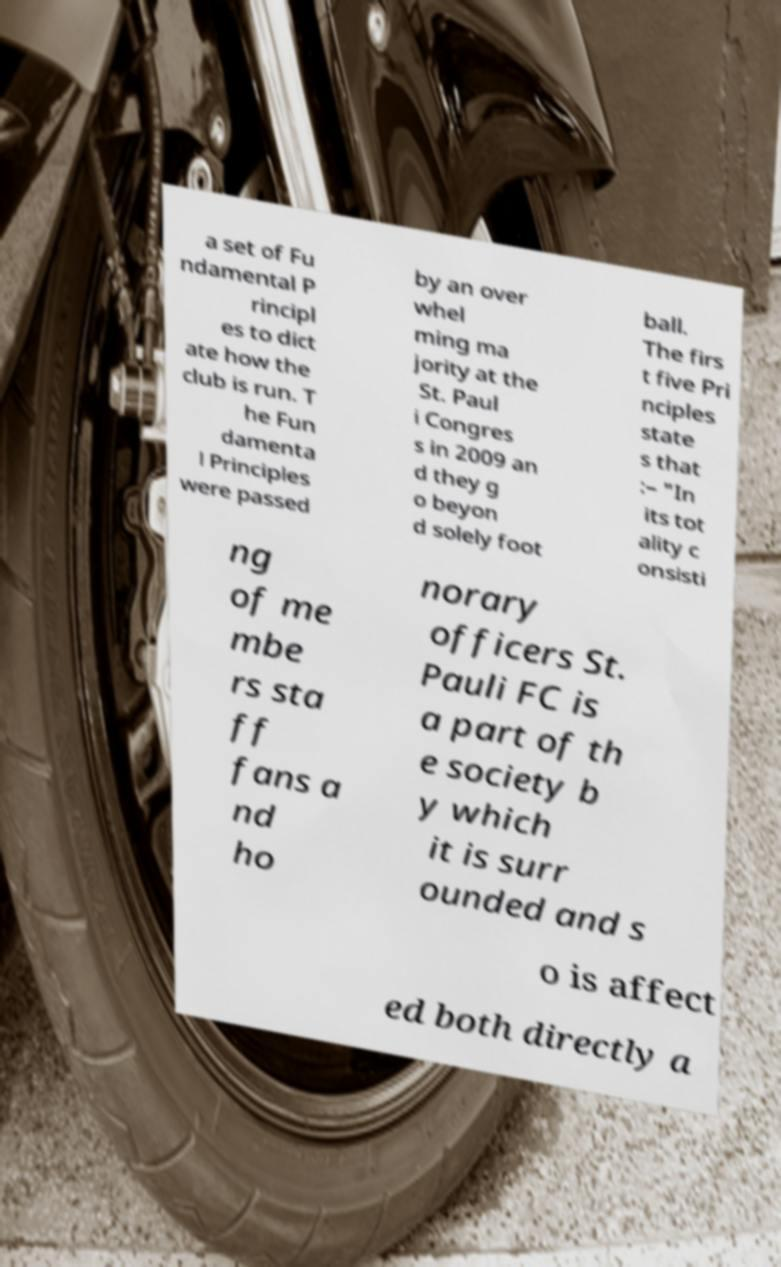Please read and relay the text visible in this image. What does it say? a set of Fu ndamental P rincipl es to dict ate how the club is run. T he Fun damenta l Principles were passed by an over whel ming ma jority at the St. Paul i Congres s in 2009 an d they g o beyon d solely foot ball. The firs t five Pri nciples state s that :– "In its tot ality c onsisti ng of me mbe rs sta ff fans a nd ho norary officers St. Pauli FC is a part of th e society b y which it is surr ounded and s o is affect ed both directly a 